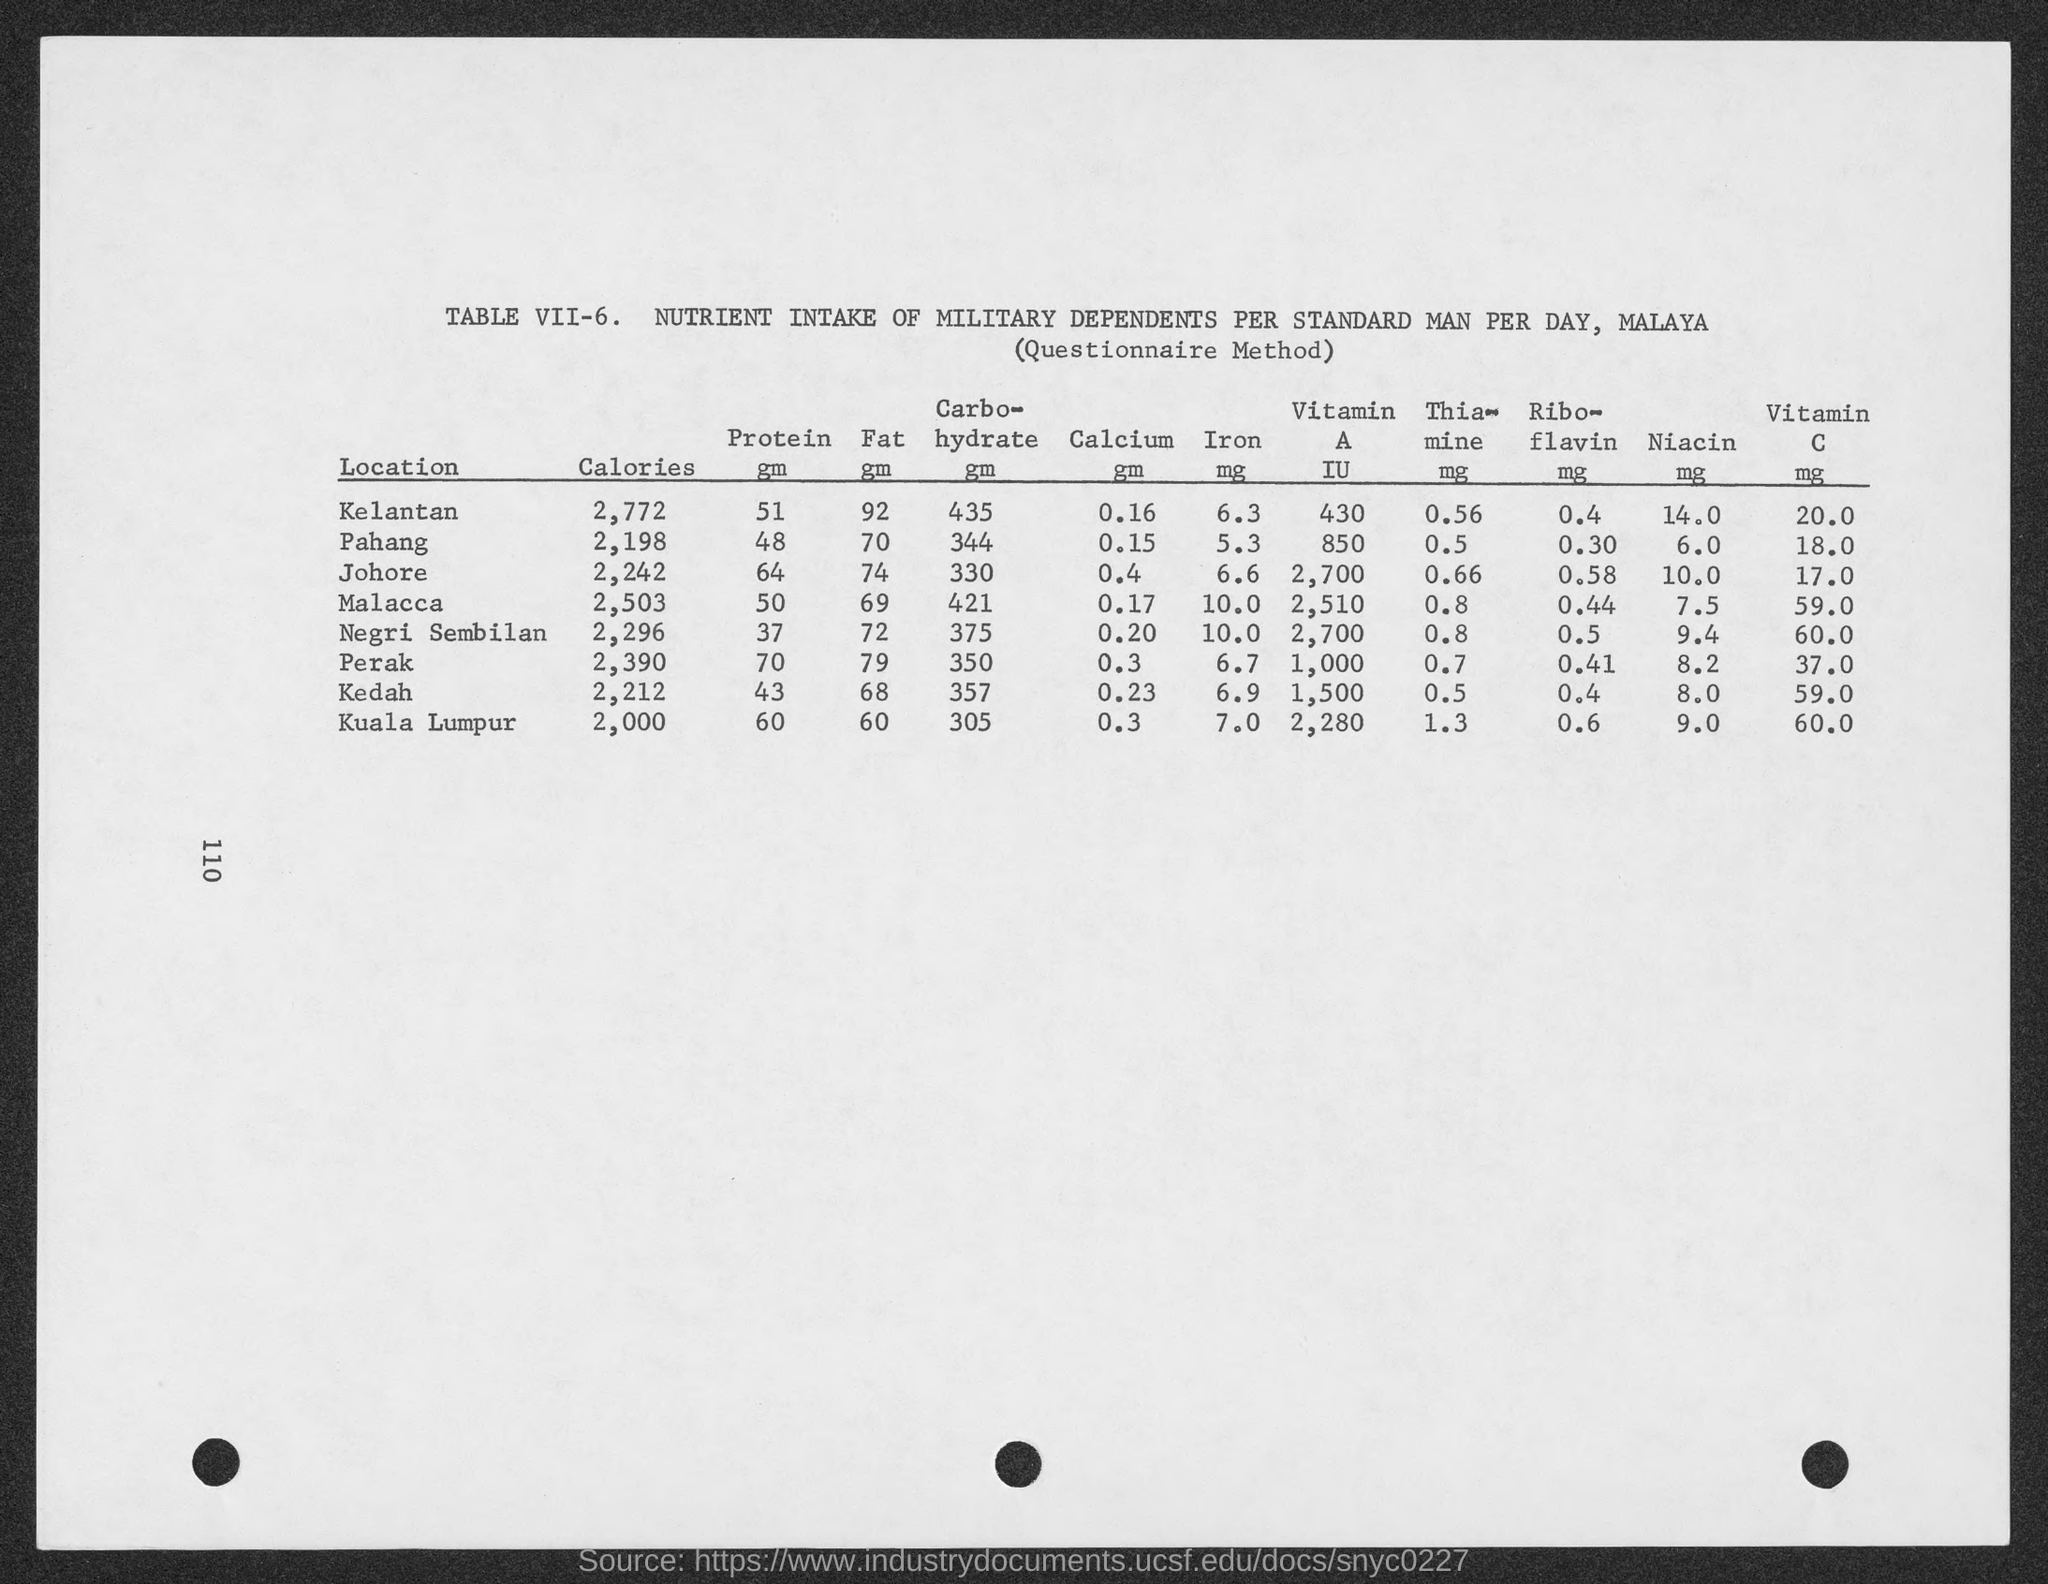Indicate a few pertinent items in this graphic. The amount of calories consumed by a stand man in the military dependent population per day in Kuala Lumpur is approximately 2,000 calories. The average daily protein intake among military dependents in Kelantan is 51 grams per stand man. The daily caloric intake for a stand man in the military dependent population in Kedah is 2,212 calories. The average daily caloric intake for military dependents in Pahang stands at 2,198 calories per stand man per day. The daily caloric intake for a stand man in the military dependent population in Negri Sembilan is 2,296 calories. 